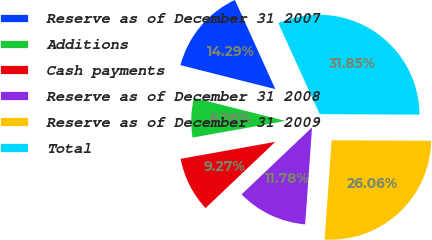Convert chart to OTSL. <chart><loc_0><loc_0><loc_500><loc_500><pie_chart><fcel>Reserve as of December 31 2007<fcel>Additions<fcel>Cash payments<fcel>Reserve as of December 31 2008<fcel>Reserve as of December 31 2009<fcel>Total<nl><fcel>14.29%<fcel>6.76%<fcel>9.27%<fcel>11.78%<fcel>26.06%<fcel>31.85%<nl></chart> 